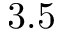Convert formula to latex. <formula><loc_0><loc_0><loc_500><loc_500>3 . 5</formula> 